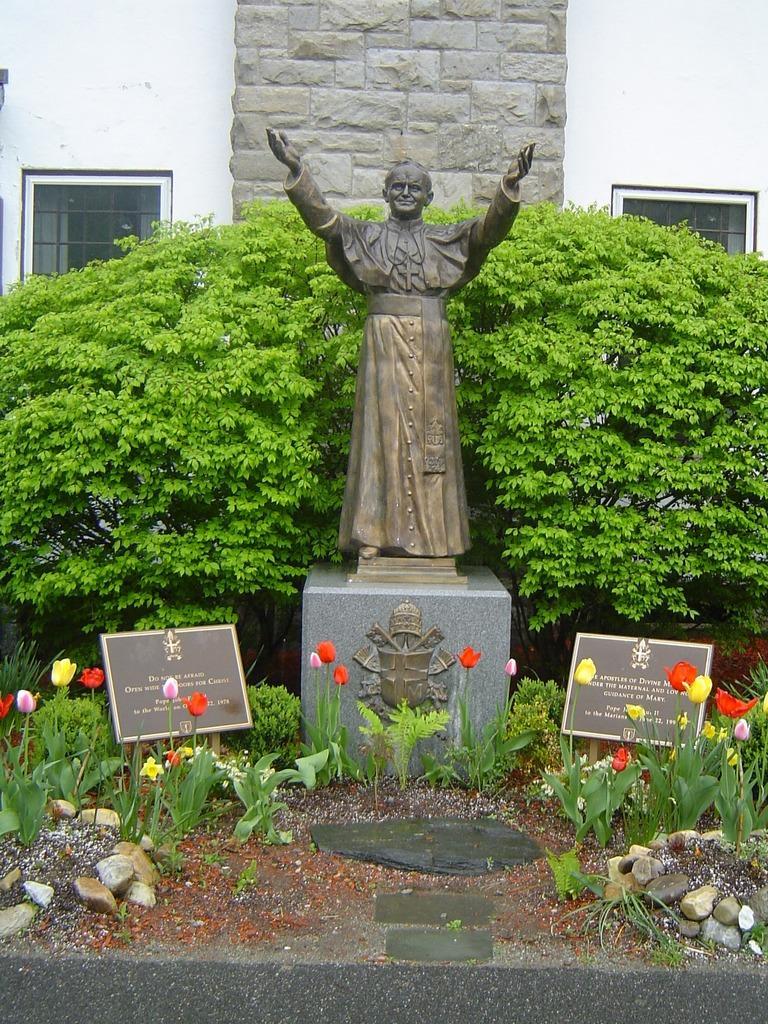Could you give a brief overview of what you see in this image? In this picture I can see a sculpture of a person, there are boards, plants, flowers, grass, there are trees, and in the background there is a wall with windows. 